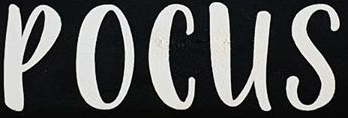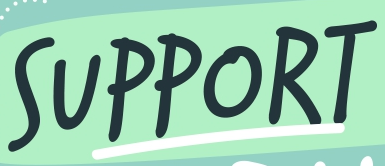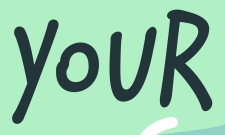What words are shown in these images in order, separated by a semicolon? POCUS; SUPPORT; YOUR 